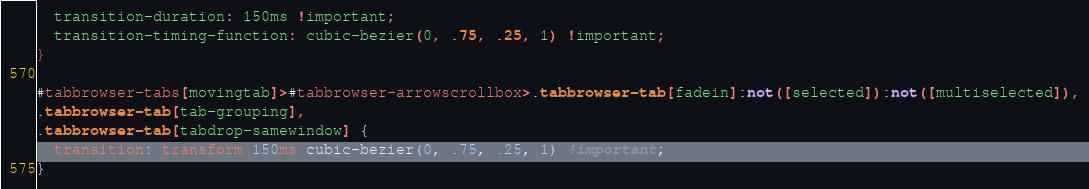Convert code to text. <code><loc_0><loc_0><loc_500><loc_500><_CSS_>  transition-duration: 150ms !important;
  transition-timing-function: cubic-bezier(0, .75, .25, 1) !important;
}

#tabbrowser-tabs[movingtab]>#tabbrowser-arrowscrollbox>.tabbrowser-tab[fadein]:not([selected]):not([multiselected]),
.tabbrowser-tab[tab-grouping],
.tabbrowser-tab[tabdrop-samewindow] {
  transition: transform 150ms cubic-bezier(0, .75, .25, 1) !important;
}
</code> 